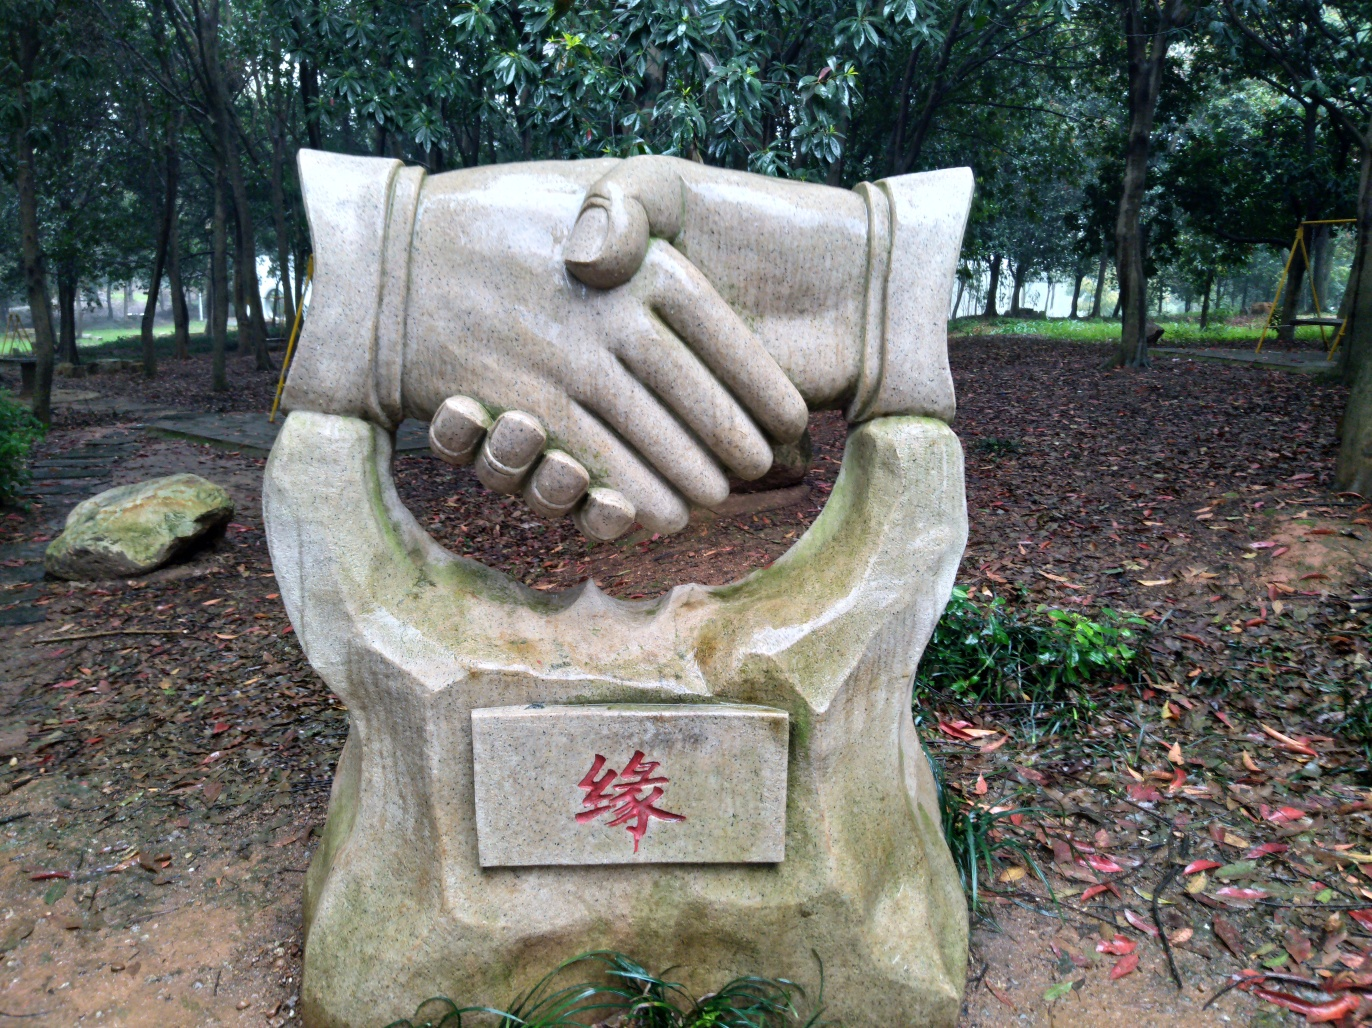What is the cultural significance of this type of sculpture? Sculptures like this often symbolize friendship, unity, or solidarity. They can be found in public spaces to promote values of togetherness and cooperation within a community or to commemorate a historical event that brought people together. How does the environment around the sculpture contribute to its overall impression? The sculpture is set amidst a natural backdrop, which may imply a harmonious relationship between humanity and nature. The surrounding trees and fallen leaves give it a serene and somewhat secluded setting, potentially inviting contemplation and emphasizing a peaceful atmosphere. 